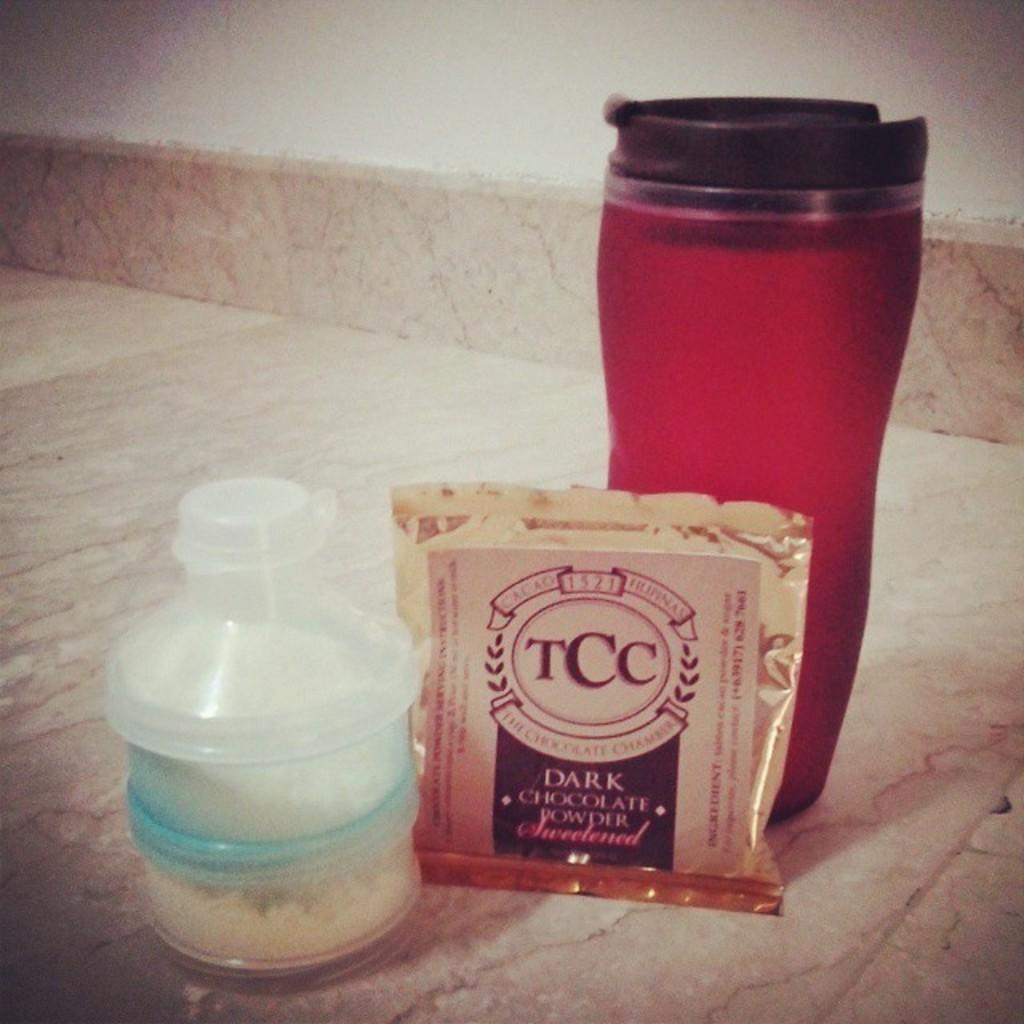<image>
Relay a brief, clear account of the picture shown. A red waterbottle is by a bag of TCC Dark Chocolate Powder. 